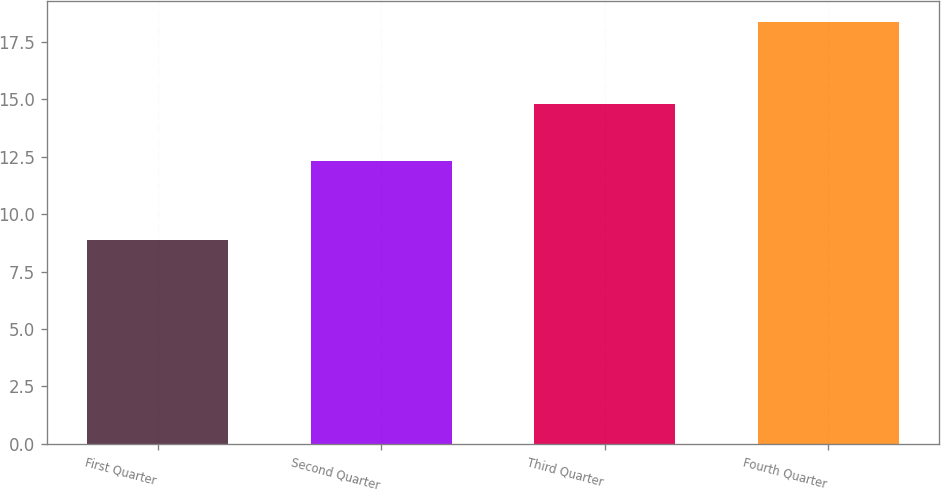Convert chart. <chart><loc_0><loc_0><loc_500><loc_500><bar_chart><fcel>First Quarter<fcel>Second Quarter<fcel>Third Quarter<fcel>Fourth Quarter<nl><fcel>8.89<fcel>12.31<fcel>14.77<fcel>18.34<nl></chart> 